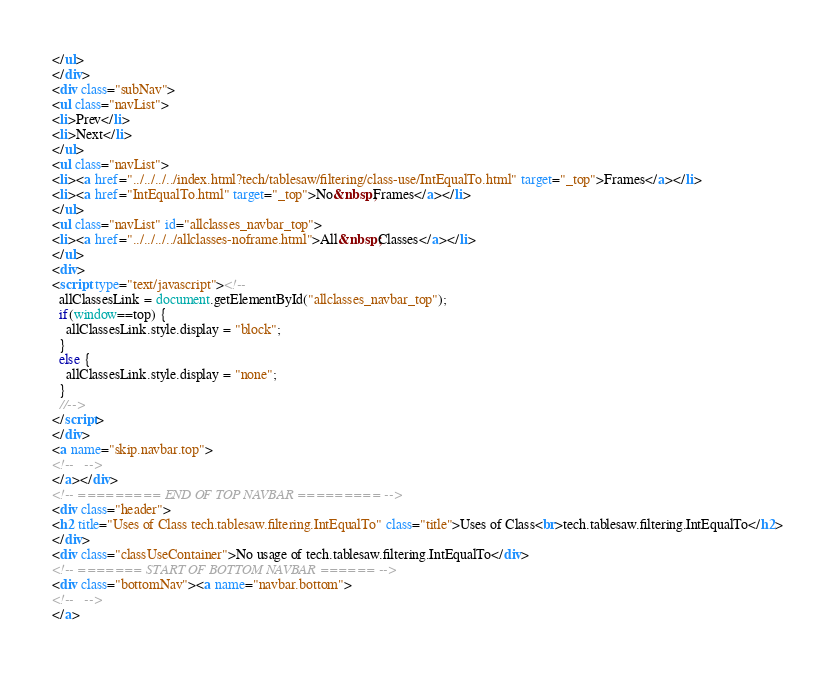<code> <loc_0><loc_0><loc_500><loc_500><_HTML_></ul>
</div>
<div class="subNav">
<ul class="navList">
<li>Prev</li>
<li>Next</li>
</ul>
<ul class="navList">
<li><a href="../../../../index.html?tech/tablesaw/filtering/class-use/IntEqualTo.html" target="_top">Frames</a></li>
<li><a href="IntEqualTo.html" target="_top">No&nbsp;Frames</a></li>
</ul>
<ul class="navList" id="allclasses_navbar_top">
<li><a href="../../../../allclasses-noframe.html">All&nbsp;Classes</a></li>
</ul>
<div>
<script type="text/javascript"><!--
  allClassesLink = document.getElementById("allclasses_navbar_top");
  if(window==top) {
    allClassesLink.style.display = "block";
  }
  else {
    allClassesLink.style.display = "none";
  }
  //-->
</script>
</div>
<a name="skip.navbar.top">
<!--   -->
</a></div>
<!-- ========= END OF TOP NAVBAR ========= -->
<div class="header">
<h2 title="Uses of Class tech.tablesaw.filtering.IntEqualTo" class="title">Uses of Class<br>tech.tablesaw.filtering.IntEqualTo</h2>
</div>
<div class="classUseContainer">No usage of tech.tablesaw.filtering.IntEqualTo</div>
<!-- ======= START OF BOTTOM NAVBAR ====== -->
<div class="bottomNav"><a name="navbar.bottom">
<!--   -->
</a></code> 